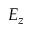<formula> <loc_0><loc_0><loc_500><loc_500>E _ { z }</formula> 